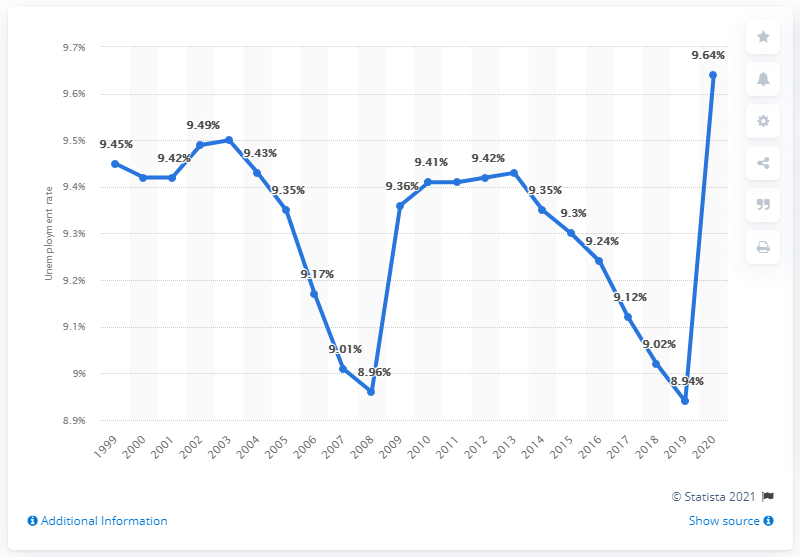Highlight a few significant elements in this photo. In 2020, the unemployment rate in the Gambia was 9.64%. 